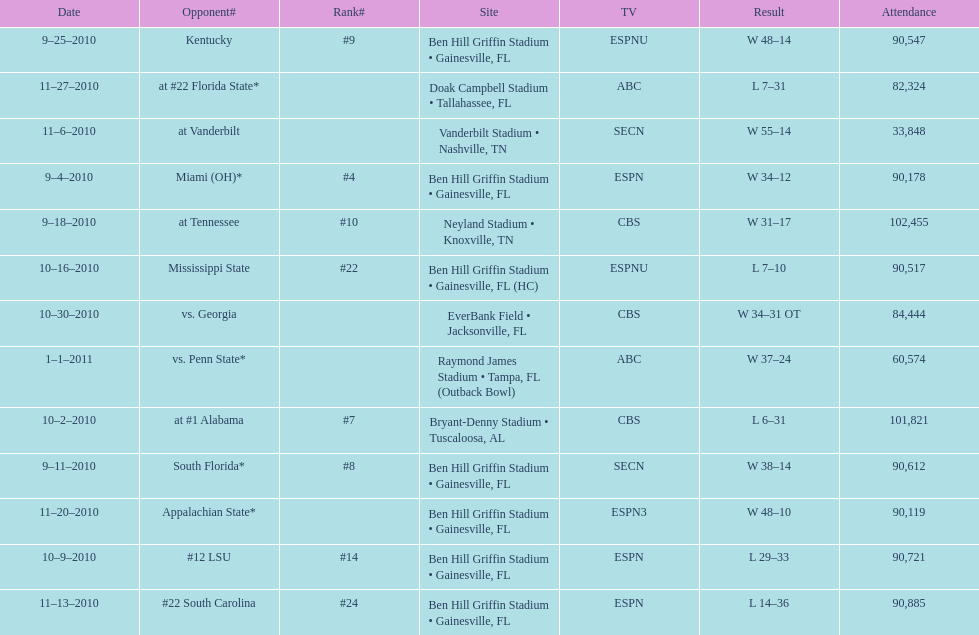What was the most the university of florida won by? 41 points. 